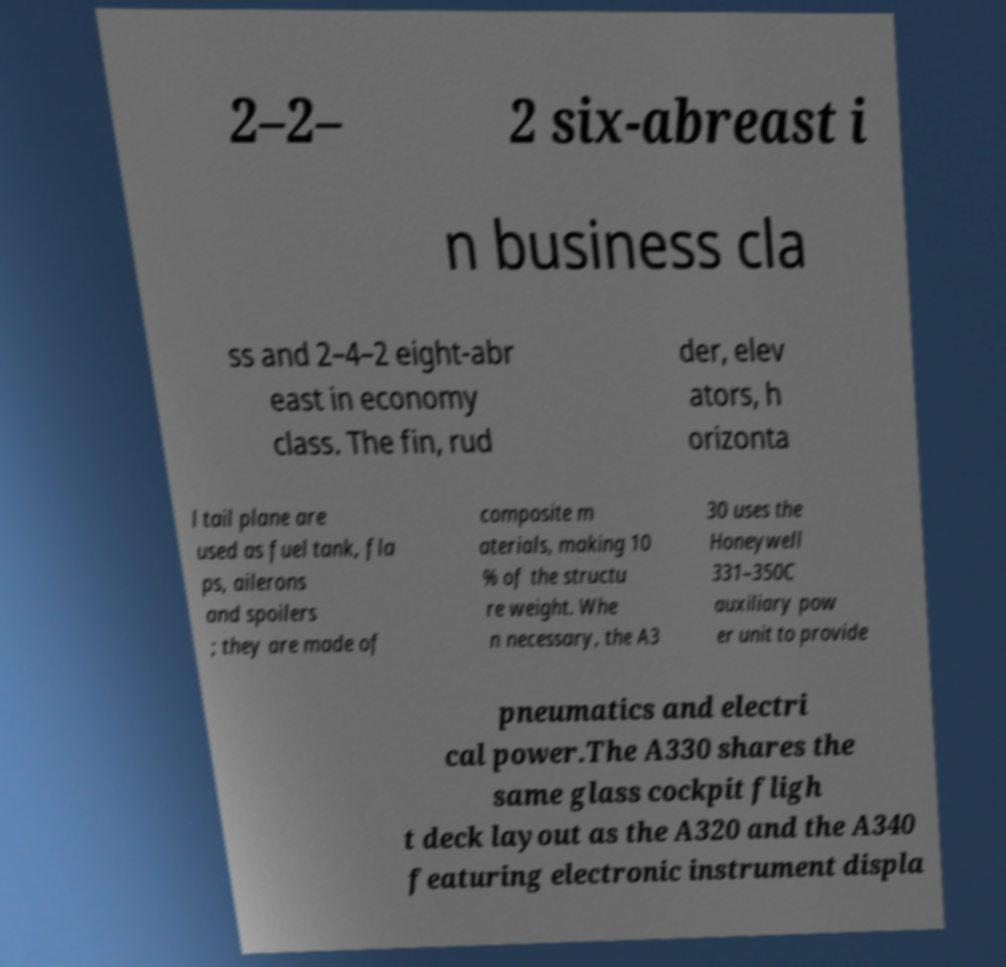I need the written content from this picture converted into text. Can you do that? 2–2– 2 six-abreast i n business cla ss and 2–4–2 eight-abr east in economy class. The fin, rud der, elev ators, h orizonta l tail plane are used as fuel tank, fla ps, ailerons and spoilers ; they are made of composite m aterials, making 10 % of the structu re weight. Whe n necessary, the A3 30 uses the Honeywell 331–350C auxiliary pow er unit to provide pneumatics and electri cal power.The A330 shares the same glass cockpit fligh t deck layout as the A320 and the A340 featuring electronic instrument displa 